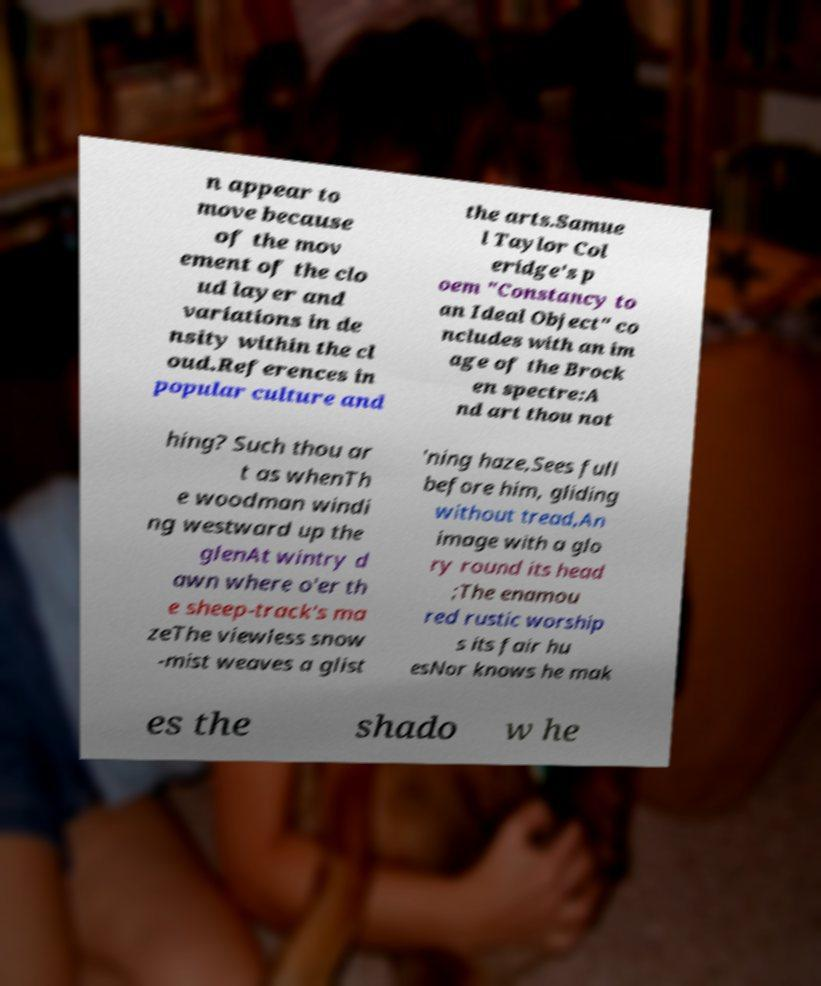Could you extract and type out the text from this image? n appear to move because of the mov ement of the clo ud layer and variations in de nsity within the cl oud.References in popular culture and the arts.Samue l Taylor Col eridge's p oem "Constancy to an Ideal Object" co ncludes with an im age of the Brock en spectre:A nd art thou not hing? Such thou ar t as whenTh e woodman windi ng westward up the glenAt wintry d awn where o'er th e sheep-track's ma zeThe viewless snow -mist weaves a glist 'ning haze,Sees full before him, gliding without tread,An image with a glo ry round its head ;The enamou red rustic worship s its fair hu esNor knows he mak es the shado w he 